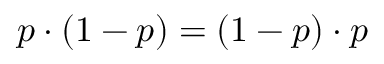Convert formula to latex. <formula><loc_0><loc_0><loc_500><loc_500>p \cdot ( 1 - p ) = ( 1 - p ) \cdot p</formula> 